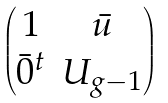<formula> <loc_0><loc_0><loc_500><loc_500>\begin{pmatrix} 1 & \bar { u } \\ \bar { 0 } ^ { t } & U _ { g - 1 } \end{pmatrix}</formula> 